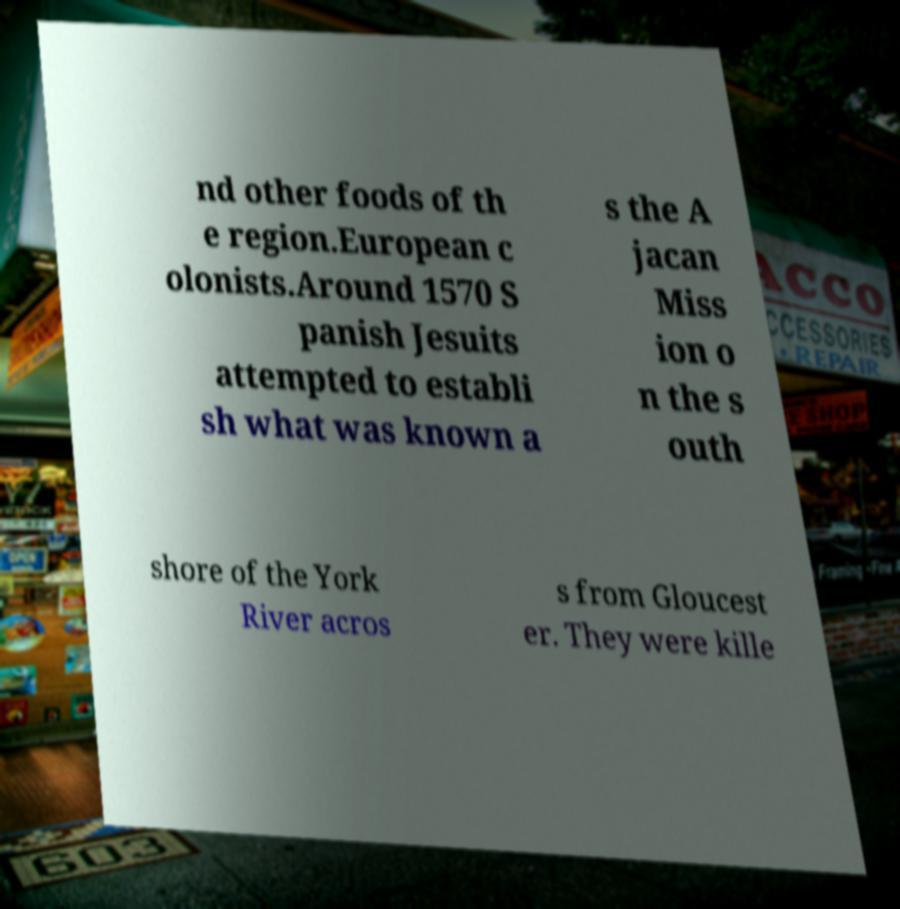There's text embedded in this image that I need extracted. Can you transcribe it verbatim? nd other foods of th e region.European c olonists.Around 1570 S panish Jesuits attempted to establi sh what was known a s the A jacan Miss ion o n the s outh shore of the York River acros s from Gloucest er. They were kille 